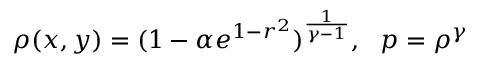<formula> <loc_0><loc_0><loc_500><loc_500>\rho ( x , y ) = ( 1 - \alpha e ^ { 1 - r ^ { 2 } } ) ^ { \frac { 1 } { \gamma - 1 } } , p = \rho ^ { \gamma }</formula> 